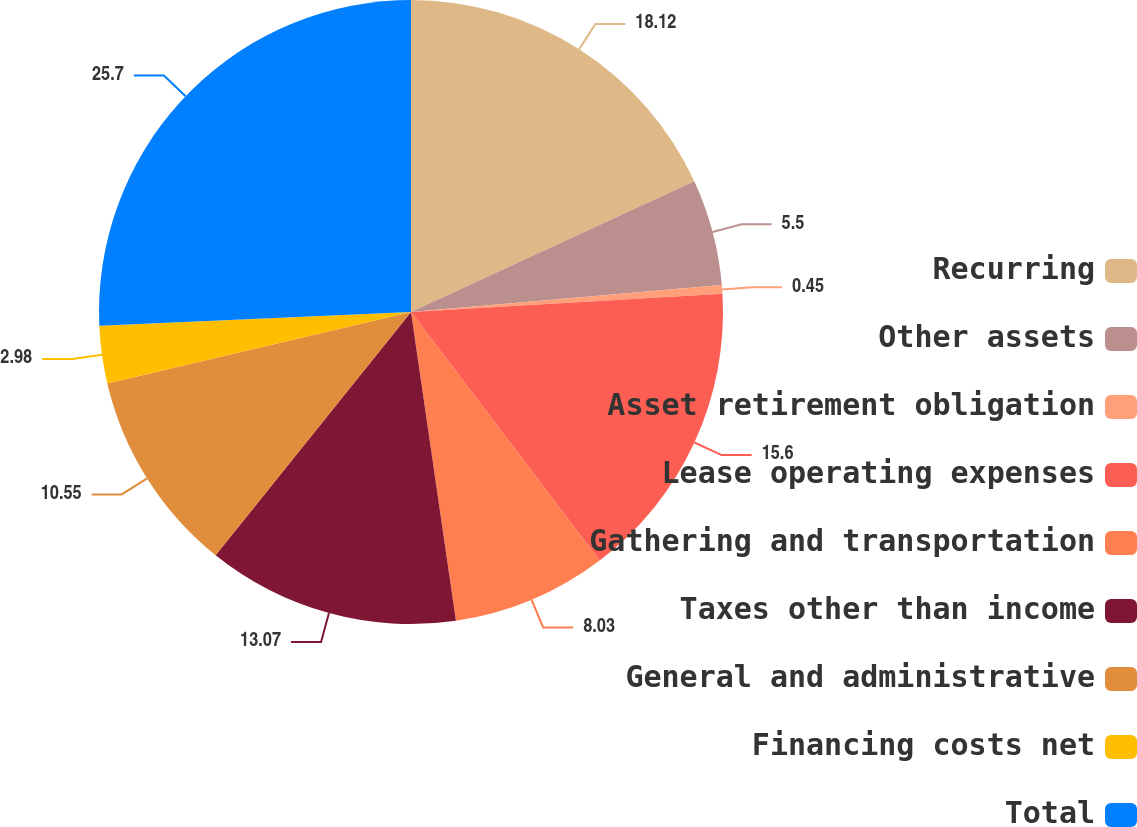Convert chart. <chart><loc_0><loc_0><loc_500><loc_500><pie_chart><fcel>Recurring<fcel>Other assets<fcel>Asset retirement obligation<fcel>Lease operating expenses<fcel>Gathering and transportation<fcel>Taxes other than income<fcel>General and administrative<fcel>Financing costs net<fcel>Total<nl><fcel>18.12%<fcel>5.5%<fcel>0.45%<fcel>15.6%<fcel>8.03%<fcel>13.07%<fcel>10.55%<fcel>2.98%<fcel>25.7%<nl></chart> 